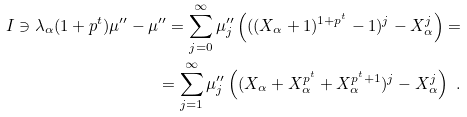Convert formula to latex. <formula><loc_0><loc_0><loc_500><loc_500>I \ni \lambda _ { \alpha } ( 1 + p ^ { t } ) \mu ^ { \prime \prime } - \mu ^ { \prime \prime } = \sum _ { j = 0 } ^ { \infty } \mu ^ { \prime \prime } _ { j } \left ( ( ( X _ { \alpha } + 1 ) ^ { 1 + p ^ { t } } - 1 ) ^ { j } - X _ { \alpha } ^ { j } \right ) = \\ = \sum _ { j = 1 } ^ { \infty } \mu ^ { \prime \prime } _ { j } \left ( ( X _ { \alpha } + X _ { \alpha } ^ { p ^ { t } } + X _ { \alpha } ^ { p ^ { t } + 1 } ) ^ { j } - X _ { \alpha } ^ { j } \right ) \ .</formula> 